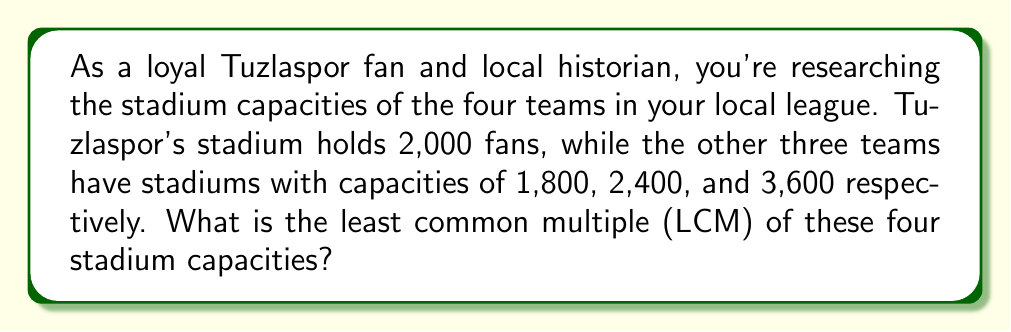What is the answer to this math problem? To find the least common multiple (LCM) of the four stadium capacities, we'll follow these steps:

1) First, list the stadium capacities:
   2,000, 1,800, 2,400, 3,600

2) Prime factorize each number:
   2,000 = $2^4 \times 5^3$
   1,800 = $2^3 \times 3^2 \times 5^2$
   2,400 = $2^5 \times 3 \times 5^2$
   3,600 = $2^4 \times 3^2 \times 5^2$

3) To find the LCM, we take each prime factor to the highest power in which it occurs in any of the numbers:

   For 2: highest power is 5 (from 2,400)
   For 3: highest power is 2 (from 1,800 and 3,600)
   For 5: highest power is 3 (from 2,000)

4) Therefore, the LCM is:

   $LCM = 2^5 \times 3^2 \times 5^3$

5) Calculate:
   $LCM = 32 \times 9 \times 125 = 36,000$

Thus, the least common multiple of the four stadium capacities is 36,000.
Answer: 36,000 